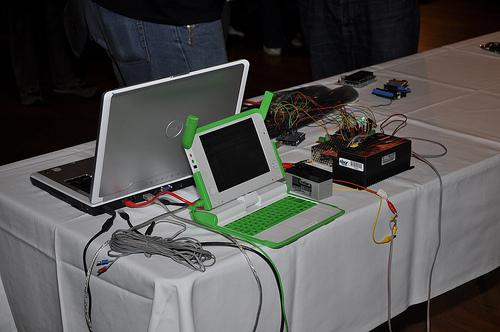Question: what is on the table?
Choices:
A. Tables.
B. Laptops.
C. Chairs.
D. Phones.
Answer with the letter. Answer: B Question: what is covering the table?
Choices:
A. Tablecloth.
B. Chair.
C. Paper.
D. Towels.
Answer with the letter. Answer: A Question: what are the laptops on?
Choices:
A. Chairs.
B. Ironing boards.
C. Table.
D. Desks.
Answer with the letter. Answer: C Question: who is on the laptop?
Choices:
A. No one.
B. Boy.
C. Girl.
D. Man.
Answer with the letter. Answer: A 